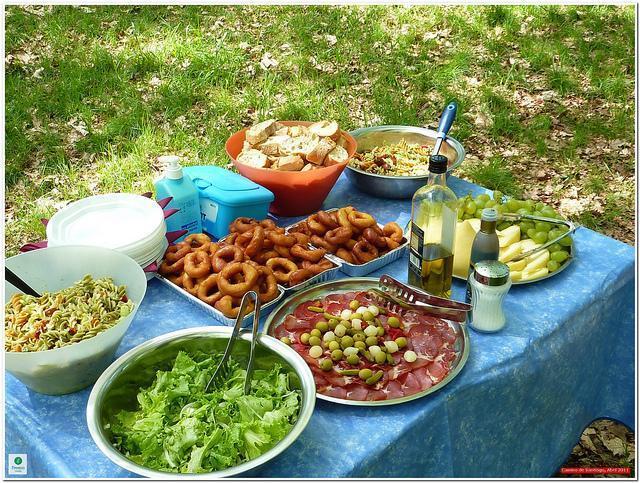How many bowls are on the table?
Give a very brief answer. 4. How many bottles can be seen?
Give a very brief answer. 2. How many bowls are in the picture?
Give a very brief answer. 4. 